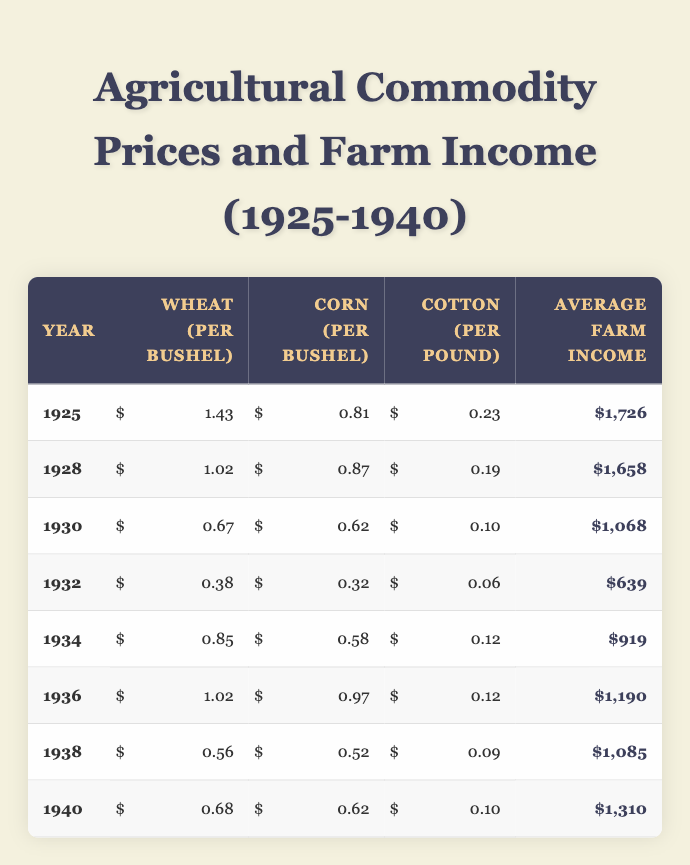What was the price of wheat per bushel in 1932? In 1932, the table indicates that the price of wheat per bushel was 0.38. This value is directly taken from the corresponding row for the year 1932.
Answer: 0.38 What was the average farm income in 1936? Referring to the table, for the year 1936, the average farm income listed is 1,190. This is obtained directly from the appropriate row for 1936.
Answer: 1,190 How much did corn prices fluctuate from 1925 to 1940? The price of corn per bushel in 1925 was 0.81 and in 1940 it was 0.62. The fluctuation can be calculated by subtracting the prices: 0.81 - 0.62 = 0.19.
Answer: 0.19 What was the combined price of cotton and wheat per pound and per bushel in 1930? In 1930, the price of cotton was 0.10 and the price of wheat was 0.67. To get the combined price, we add these two values: 0.10 + 0.67 = 0.77.
Answer: 0.77 Was the average farm income in 1934 higher than in 1928? The average farm income in 1934 was 919, while in 1928 it was 1,658. Comparing these values shows that 919 is less than 1,658, thus the statement is false.
Answer: No In which year was the lowest average farm income recorded, and what was that income? The table shows that in 1932, the average farm income was the lowest at 639. This is found by scanning through the income for each year in the table and identifying the minimum value.
Answer: 639 in 1932 Calculate the average wheat price per bushel from 1925 to 1940. The wheat prices for the years 1925, 1928, 1930, 1932, 1934, 1936, 1938, and 1940 are 1.43, 1.02, 0.67, 0.38, 0.85, 1.02, 0.56, and 0.68 respectively. The total is 1.43 + 1.02 + 0.67 + 0.38 + 0.85 + 1.02 + 0.56 + 0.68 = 6.61. Dividing by 8 years gives an average of 6.61 / 8 = 0.82625.
Answer: 0.82625 Was there a year where the price of cotton per pound increased compared to the previous year? By examining the cotton prices from year to year, I see that in 1936 it remained 0.12, then decreased to 0.09 in 1938. Between 1928 and 1930, it dropped from 0.19 in 1928 to 0.10 in 1930, showing no increase in cotton prices consecutively over the years. Thus, there was no year of increase compared to the previous.
Answer: No 